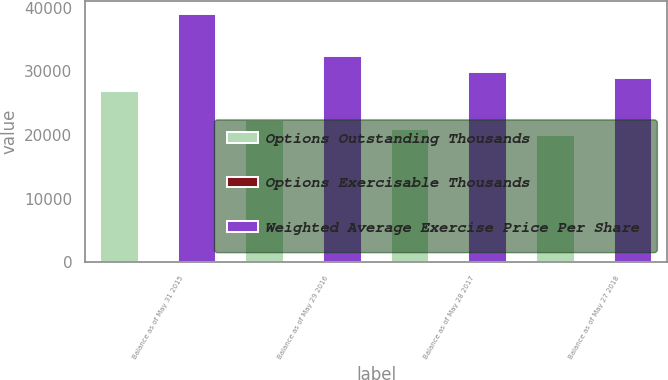Convert chart to OTSL. <chart><loc_0><loc_0><loc_500><loc_500><stacked_bar_chart><ecel><fcel>Balance as of May 31 2015<fcel>Balance as of May 29 2016<fcel>Balance as of May 28 2017<fcel>Balance as of May 27 2018<nl><fcel>Options Outstanding Thousands<fcel>26991.5<fcel>22385.1<fcel>20899.2<fcel>20021.1<nl><fcel>Options Exercisable Thousands<fcel>30.44<fcel>32.38<fcel>33.83<fcel>36.15<nl><fcel>Weighted Average Exercise Price Per Share<fcel>39077.2<fcel>32401.6<fcel>29834.4<fcel>28963.8<nl></chart> 